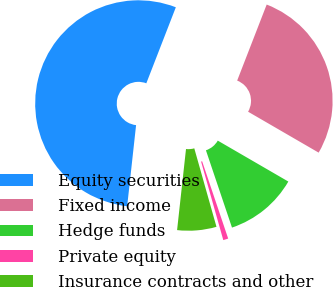<chart> <loc_0><loc_0><loc_500><loc_500><pie_chart><fcel>Equity securities<fcel>Fixed income<fcel>Hedge funds<fcel>Private equity<fcel>Insurance contracts and other<nl><fcel>54.15%<fcel>27.47%<fcel>11.46%<fcel>0.79%<fcel>6.13%<nl></chart> 